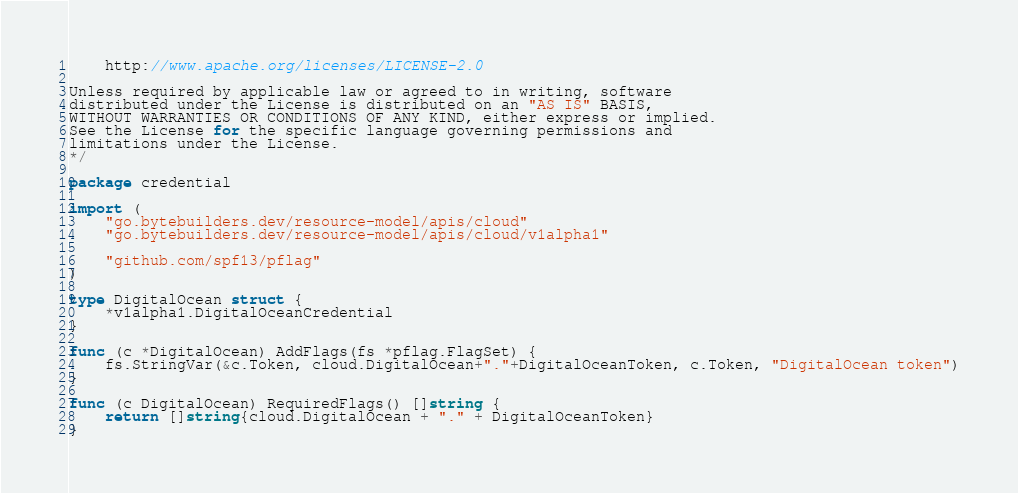<code> <loc_0><loc_0><loc_500><loc_500><_Go_>
    http://www.apache.org/licenses/LICENSE-2.0

Unless required by applicable law or agreed to in writing, software
distributed under the License is distributed on an "AS IS" BASIS,
WITHOUT WARRANTIES OR CONDITIONS OF ANY KIND, either express or implied.
See the License for the specific language governing permissions and
limitations under the License.
*/

package credential

import (
	"go.bytebuilders.dev/resource-model/apis/cloud"
	"go.bytebuilders.dev/resource-model/apis/cloud/v1alpha1"

	"github.com/spf13/pflag"
)

type DigitalOcean struct {
	*v1alpha1.DigitalOceanCredential
}

func (c *DigitalOcean) AddFlags(fs *pflag.FlagSet) {
	fs.StringVar(&c.Token, cloud.DigitalOcean+"."+DigitalOceanToken, c.Token, "DigitalOcean token")
}

func (c DigitalOcean) RequiredFlags() []string {
	return []string{cloud.DigitalOcean + "." + DigitalOceanToken}
}
</code> 